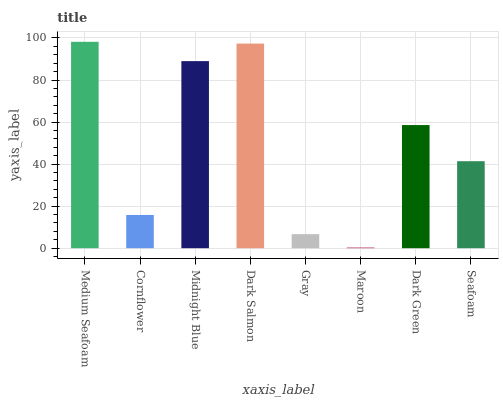Is Maroon the minimum?
Answer yes or no. Yes. Is Medium Seafoam the maximum?
Answer yes or no. Yes. Is Cornflower the minimum?
Answer yes or no. No. Is Cornflower the maximum?
Answer yes or no. No. Is Medium Seafoam greater than Cornflower?
Answer yes or no. Yes. Is Cornflower less than Medium Seafoam?
Answer yes or no. Yes. Is Cornflower greater than Medium Seafoam?
Answer yes or no. No. Is Medium Seafoam less than Cornflower?
Answer yes or no. No. Is Dark Green the high median?
Answer yes or no. Yes. Is Seafoam the low median?
Answer yes or no. Yes. Is Medium Seafoam the high median?
Answer yes or no. No. Is Midnight Blue the low median?
Answer yes or no. No. 